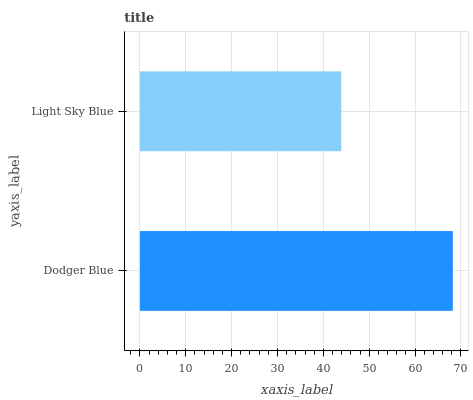Is Light Sky Blue the minimum?
Answer yes or no. Yes. Is Dodger Blue the maximum?
Answer yes or no. Yes. Is Light Sky Blue the maximum?
Answer yes or no. No. Is Dodger Blue greater than Light Sky Blue?
Answer yes or no. Yes. Is Light Sky Blue less than Dodger Blue?
Answer yes or no. Yes. Is Light Sky Blue greater than Dodger Blue?
Answer yes or no. No. Is Dodger Blue less than Light Sky Blue?
Answer yes or no. No. Is Dodger Blue the high median?
Answer yes or no. Yes. Is Light Sky Blue the low median?
Answer yes or no. Yes. Is Light Sky Blue the high median?
Answer yes or no. No. Is Dodger Blue the low median?
Answer yes or no. No. 